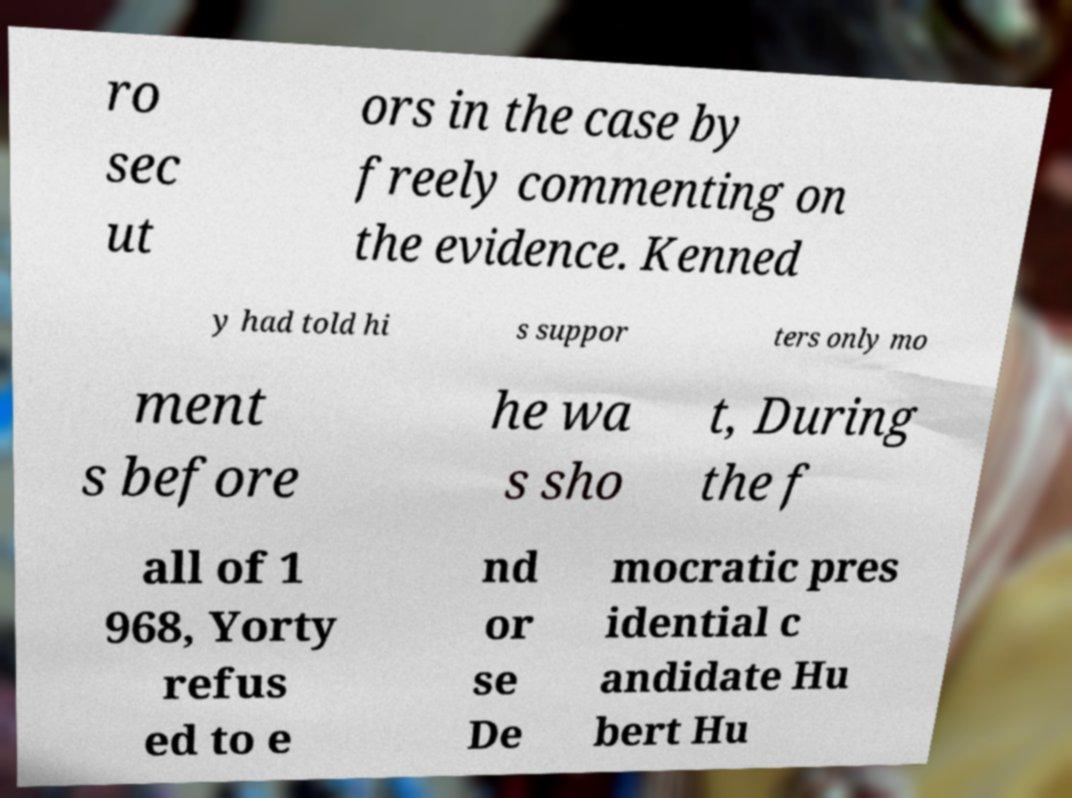Please read and relay the text visible in this image. What does it say? ro sec ut ors in the case by freely commenting on the evidence. Kenned y had told hi s suppor ters only mo ment s before he wa s sho t, During the f all of 1 968, Yorty refus ed to e nd or se De mocratic pres idential c andidate Hu bert Hu 